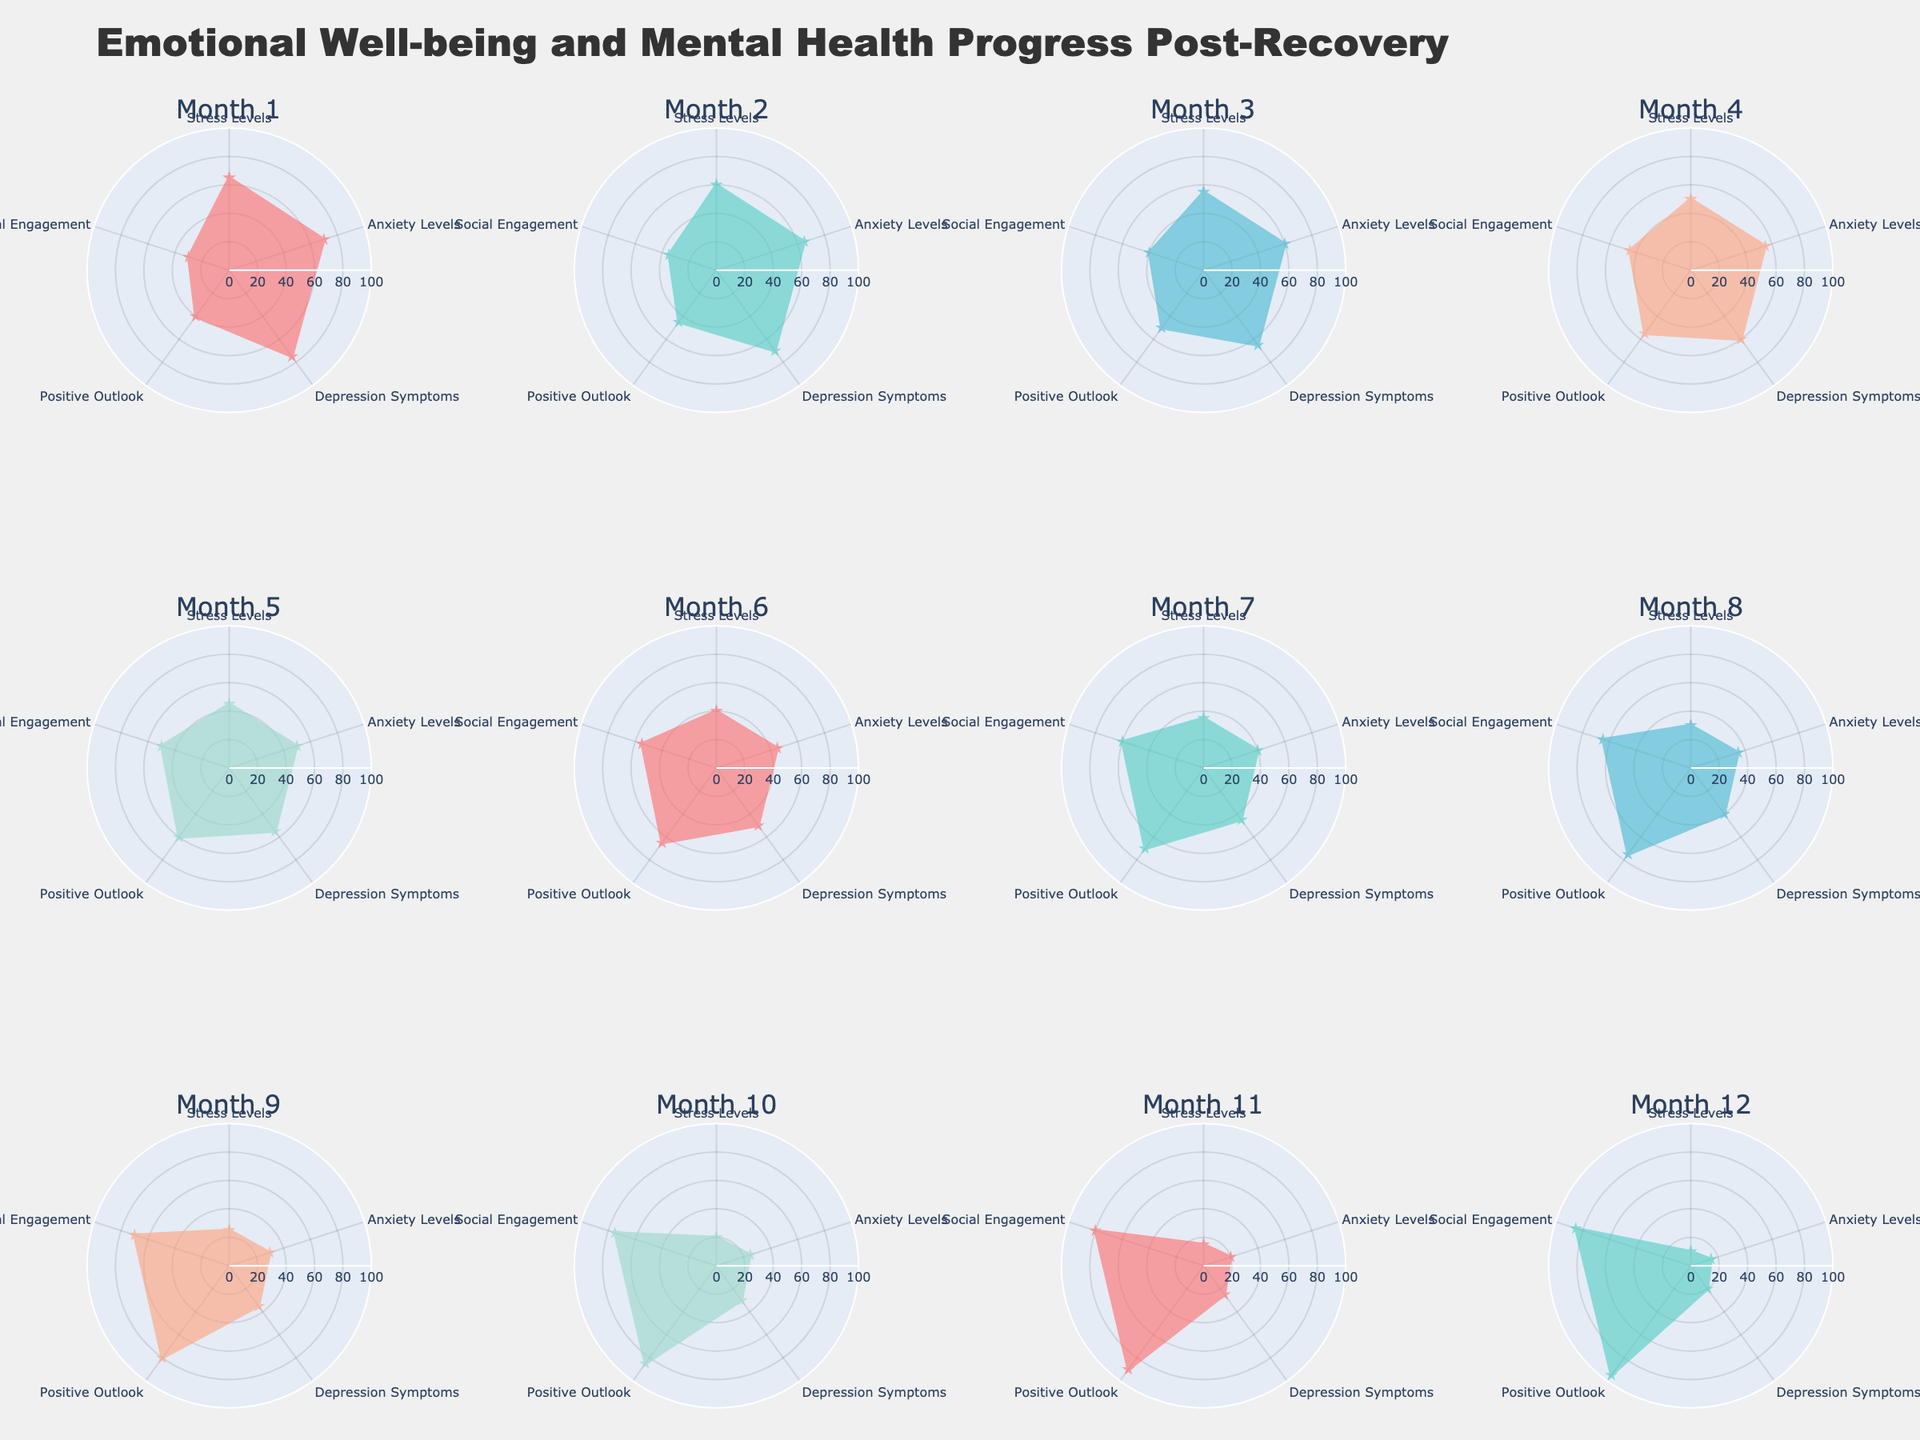What is the title of the figure? The title is clearly displayed at the top of the figure in a larger and bold font. It reads "Emotional Well-being and Mental Health Progress Post-Recovery".
Answer: Emotional Well-being and Mental Health Progress Post-Recovery How many subplots does the figure contain, and how are they organized? The figure contains 12 subplots, organized in a grid of 3 rows and 4 columns. Each subplot represents one month of data from month 1 to month 12.
Answer: 12 subplots, organized in 3 rows and 4 columns Which month shows the highest value for Positive Outlook? To determine this, look at the subplots individually and compare the values for the Positive Outlook in each. The month with the highest value is month 12.
Answer: Month 12 What is the range of the radial axis in the radar charts? The radial axis is visible on each radar chart and shows the range from 0 to 100, as indicated by the tick marks.
Answer: 0 to 100 How do the values for Stress Levels change over time? By examining the values for Stress Levels across all subplots, we see a steady decrease in values from month 1 (65) to month 12 (10). This indicates an improvement over time.
Answer: They steadily decrease What is the most prominent color used for the plotted lines and filled areas in the subcharts? The colors used are visually distinct, and each subplot seems to use variations of the same set of colors. However, the most prominent colors used are red, teal, blue, orange, and light green.
Answer: Red, teal, blue, orange, light green Compare Social Engagement levels between month 1 and month 12. Which month had higher engagement? By examining the two subplots for month 1 and month 12, we note the values of Social Engagement are 30 for month 1 and 85 for month 12. Month 12 has higher engagement.
Answer: Month 12 What pattern do you observe for Depression Symptoms over the 12 months? Observing the values for Depression Symptoms across all subplots, there is a consistent decrease from month 1 (75) to month 12 (20), indicating improvement.
Answer: Consistent decrease Which category shows the most significant improvement from month 1 to month 12? By comparing the values of each category from month 1 and month 12, we notice that Positive Outlook has the most significant improvement (from 40 to 95).
Answer: Positive Outlook How does the Anxiety Levels trend compare to the trend of Positive Outlook? Anxiety Levels decrease from month 1 to month 12 (70 to 15), while Positive Outlook increases over the same period (40 to 95). These two trends are inversely related.
Answer: Inversely related 